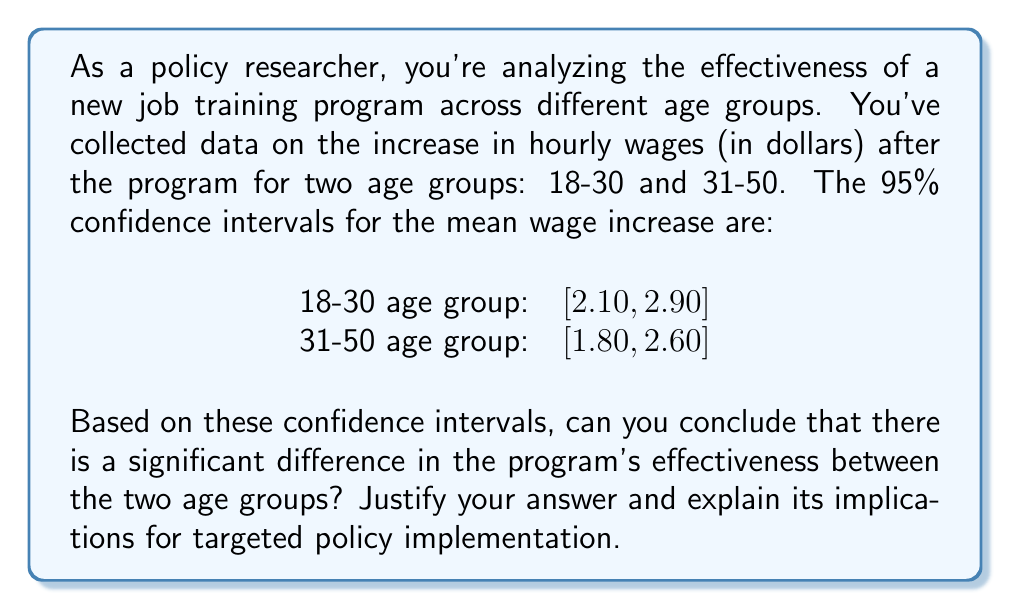What is the answer to this math problem? To determine if there's a significant difference between the two age groups, we need to examine the overlap of their confidence intervals. Here's the step-by-step analysis:

1) First, let's visualize the confidence intervals:

   [asy]
   size(300,100);
   real xmin = 1.5, xmax = 3.2;
   real ymin = 0, ymax = 2;
   
   xaxis("Wage Increase ($)", xmin, xmax, Arrow);
   yaxis("Age Group", ymin, ymax, Arrow);
   
   draw((2.10,1)--(2.90,1), blue+1);
   draw((1.80,2)--(2.60,2), red+1);
   
   label("18-30", (1.7,1), W);
   label("31-50", (1.7,2), W);
   [/asy]

2) We observe that the confidence intervals overlap.

3) When confidence intervals overlap, we cannot conclude that there is a statistically significant difference between the groups at the 95% confidence level.

4) The overlap indicates that the true population means for both age groups could potentially be the same value within the overlapping region.

5) To quantify the overlap, we can calculate:
   Overlap range = $[max(2.10, 1.80), min(2.90, 2.60)] = [2.10, 2.60]$

6) This substantial overlap (0.50 dollars) suggests that the difference in program effectiveness between the two age groups may not be statistically significant.

7) For policy implications:
   - We cannot justify age-specific modifications to the program based on this data alone.
   - The program appears to have a positive effect on both age groups (both CIs are above 0).
   - Further research or larger sample sizes might be needed to detect any potential age-related differences.

8) If policymakers want to implement targeted policies, they would need stronger evidence of differential effects across age groups.
Answer: No significant difference; overlapping CIs ([$2.10, $2.60]) indicate similar program effectiveness across age groups. 